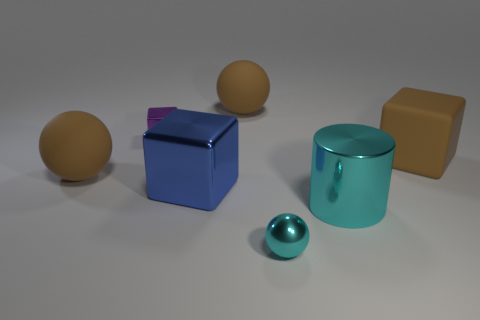What is the color of the object that is both in front of the tiny cube and on the left side of the blue metal block?
Provide a succinct answer. Brown. Is the number of brown spheres in front of the small cyan sphere greater than the number of cyan metal balls that are right of the big cyan metal cylinder?
Your answer should be very brief. No. The rubber object in front of the large brown rubber cube is what color?
Make the answer very short. Brown. There is a big brown thing behind the large rubber cube; is its shape the same as the large rubber object to the right of the small cyan thing?
Offer a terse response. No. Are there any cylinders that have the same size as the blue thing?
Your answer should be very brief. Yes. There is a block that is in front of the matte cube; what material is it?
Ensure brevity in your answer.  Metal. Is the material of the big block to the right of the tiny cyan object the same as the tiny cyan ball?
Give a very brief answer. No. Are there any big red rubber cylinders?
Ensure brevity in your answer.  No. The tiny sphere that is the same material as the blue object is what color?
Make the answer very short. Cyan. There is a large object that is left of the tiny thing that is behind the cyan metal thing that is on the left side of the cyan metal cylinder; what is its color?
Your answer should be compact. Brown. 